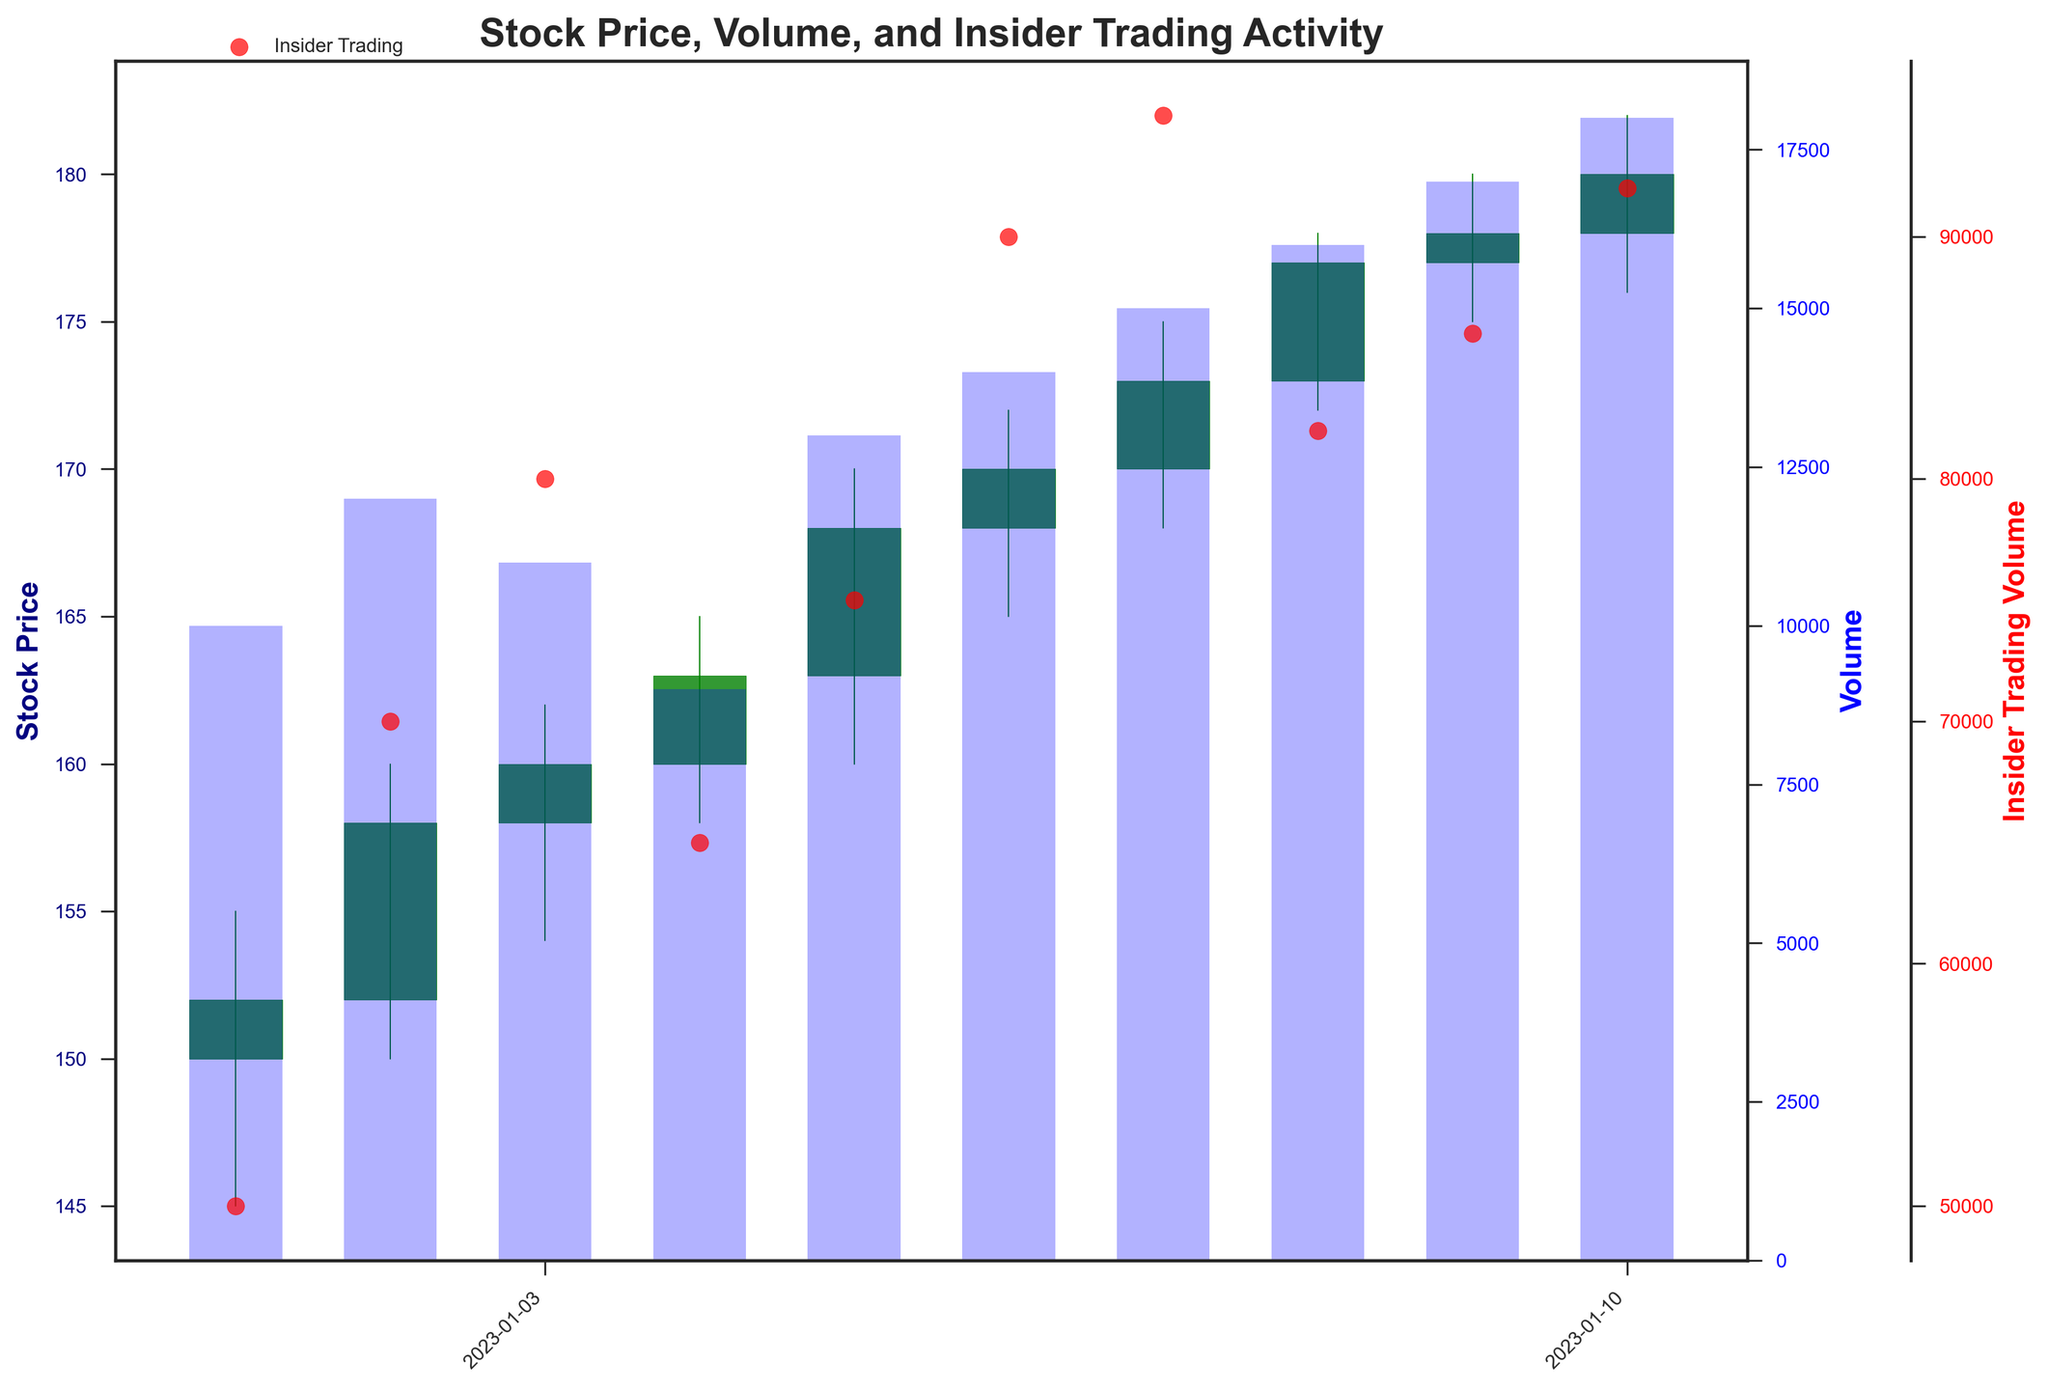What is the title of the figure? The title is usually displayed at the top of the figure. By looking at that area, you can read the given title.
Answer: Stock Price, Volume, and Insider Trading Activity What is the general trend of the stock price from January 1, 2023, to January 10, 2023? By observing the candlesticks, you can see a general upward movement in the stock prices over this period.
Answer: Upward trend How does the shading/color of the candlesticks represent stock movements? Green candlesticks indicate stock prices closing higher than the opening prices, while red candlesticks indicate prices closing lower than the opening prices.
Answer: Green for price increase, red for decrease What is the highest insider trading volume recorded in the figure, and on what date does it occur? Look at the red scatter points representing insider trading volumes, and identify the highest one along the y-axis, noting the corresponding date on the x-axis.
Answer: 95,000 on January 7, 2023 How does the volume of stocks traded generally trend compared to the insider trading volumes over the same period? By comparing the blue bars (stock volume) and the red scatter points (insider trading volume), you can see if they exhibit similar trends (e.g., both increasing or both decreasing) or disparate ones.
Answer: Both generally increasing Between January 2, 2023, and January 5, 2023, on which date was the stock price volatility the highest? Stock price volatility can be inferred from the height of the candlestick's body and wicks (high-low range). Compare the heights between these dates to identify the highest volatility.
Answer: January 5, 2023 Is there any relationship between high-volume trading days and insider trading activities? Compare the days with high blue bars to the days with high red scatter points to look for any overlap or patterns.
Answer: Often coinciding What can we infer about the changes in stock price when there are large insider trades? Focus on the dates with the largest red scatter points (indicating high insider trades), and observe the corresponding candlesticks to infer if these insider trades tend to precede or follow significant stock price movements.
Answer: Large insider trades often precede stock price increases Which date shows the highest closing price, and what is that price? Look at the figure's rightmost part of the candlesticks for the closing prices, then find the highest point and note the date.
Answer: January 10, 2023, at 180 How does the stock volume on January 7, 2023, compare to other days? Look at the height of the blue bar representing the stock volume for January 7 and compare it to the other blue bars for different days.
Answer: Higher than most other days 